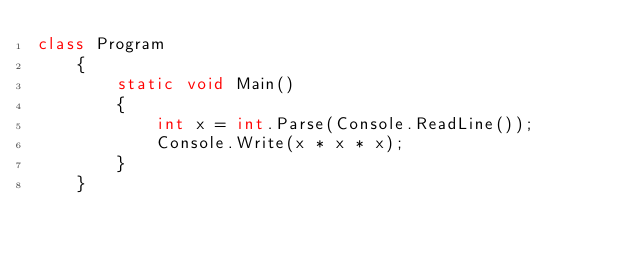Convert code to text. <code><loc_0><loc_0><loc_500><loc_500><_C#_>class Program
    { 
        static void Main()
        {
            int x = int.Parse(Console.ReadLine());
            Console.Write(x * x * x);
        }
    }</code> 